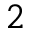Convert formula to latex. <formula><loc_0><loc_0><loc_500><loc_500>^ { 2 }</formula> 